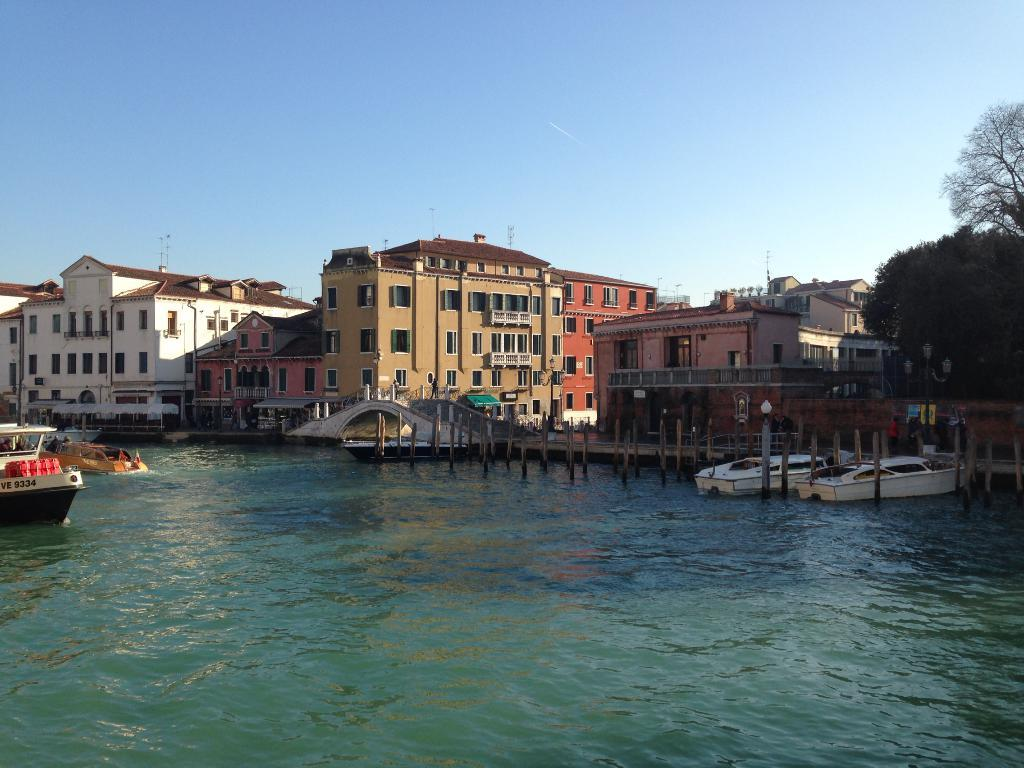What is on the water in the image? There are boats on the water in the image. What else can be seen in the image besides the boats? Buildings, light poles, trees, and clouds are visible in the image. Where are the trees located in the image? The trees are on the right side of the image. What is visible in the sky in the image? Clouds are visible in the sky in the image. Can you see a flame coming from the light poles in the image? There is no flame present on the light poles in the image. How long does it take for the hand to appear in the image? There is no hand present in the image. 